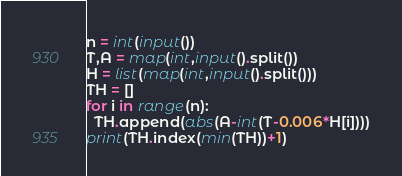Convert code to text. <code><loc_0><loc_0><loc_500><loc_500><_Python_>n = int(input())
T,A = map(int,input().split())
H = list(map(int,input().split()))
TH = []
for i in range(n):
  TH.append(abs(A-int(T-0.006*H[i])))
print(TH.index(min(TH))+1)</code> 